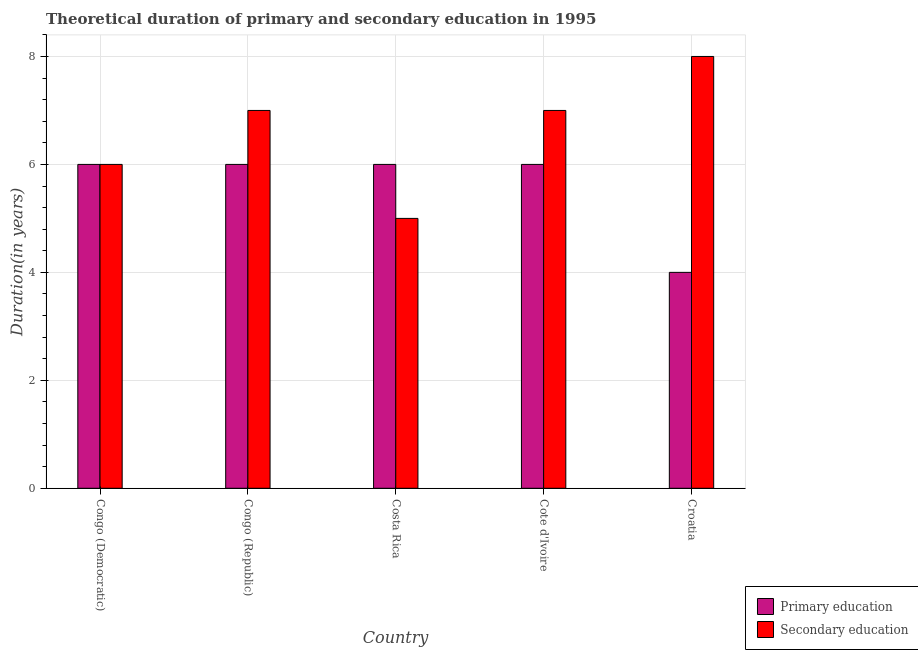How many different coloured bars are there?
Offer a terse response. 2. How many groups of bars are there?
Give a very brief answer. 5. How many bars are there on the 3rd tick from the left?
Provide a succinct answer. 2. How many bars are there on the 5th tick from the right?
Your answer should be very brief. 2. What is the label of the 2nd group of bars from the left?
Make the answer very short. Congo (Republic). In how many cases, is the number of bars for a given country not equal to the number of legend labels?
Offer a very short reply. 0. What is the duration of secondary education in Cote d'Ivoire?
Offer a very short reply. 7. Across all countries, what is the maximum duration of secondary education?
Your answer should be very brief. 8. Across all countries, what is the minimum duration of primary education?
Offer a terse response. 4. In which country was the duration of primary education maximum?
Offer a terse response. Congo (Democratic). In which country was the duration of secondary education minimum?
Make the answer very short. Costa Rica. What is the total duration of secondary education in the graph?
Offer a terse response. 33. What is the difference between the duration of secondary education in Congo (Democratic) and that in Congo (Republic)?
Your answer should be compact. -1. What is the difference between the duration of secondary education in Croatia and the duration of primary education in Cote d'Ivoire?
Provide a short and direct response. 2. What is the difference between the duration of primary education and duration of secondary education in Congo (Republic)?
Give a very brief answer. -1. What is the ratio of the duration of primary education in Cote d'Ivoire to that in Croatia?
Keep it short and to the point. 1.5. What is the difference between the highest and the second highest duration of secondary education?
Provide a succinct answer. 1. What is the difference between the highest and the lowest duration of secondary education?
Offer a terse response. 3. Is the sum of the duration of secondary education in Costa Rica and Croatia greater than the maximum duration of primary education across all countries?
Your answer should be very brief. Yes. What does the 1st bar from the left in Costa Rica represents?
Keep it short and to the point. Primary education. How many countries are there in the graph?
Give a very brief answer. 5. What is the difference between two consecutive major ticks on the Y-axis?
Make the answer very short. 2. Does the graph contain any zero values?
Offer a terse response. No. Does the graph contain grids?
Provide a short and direct response. Yes. Where does the legend appear in the graph?
Your response must be concise. Bottom right. What is the title of the graph?
Provide a short and direct response. Theoretical duration of primary and secondary education in 1995. What is the label or title of the Y-axis?
Keep it short and to the point. Duration(in years). What is the Duration(in years) in Primary education in Congo (Republic)?
Offer a very short reply. 6. What is the Duration(in years) in Primary education in Costa Rica?
Provide a short and direct response. 6. What is the Duration(in years) in Secondary education in Costa Rica?
Provide a succinct answer. 5. What is the Duration(in years) in Primary education in Cote d'Ivoire?
Your response must be concise. 6. What is the Duration(in years) in Secondary education in Cote d'Ivoire?
Provide a short and direct response. 7. What is the Duration(in years) of Primary education in Croatia?
Keep it short and to the point. 4. What is the Duration(in years) of Secondary education in Croatia?
Provide a succinct answer. 8. What is the total Duration(in years) in Secondary education in the graph?
Give a very brief answer. 33. What is the difference between the Duration(in years) in Secondary education in Congo (Democratic) and that in Costa Rica?
Provide a short and direct response. 1. What is the difference between the Duration(in years) in Secondary education in Congo (Republic) and that in Cote d'Ivoire?
Give a very brief answer. 0. What is the difference between the Duration(in years) of Secondary education in Congo (Republic) and that in Croatia?
Give a very brief answer. -1. What is the difference between the Duration(in years) of Primary education in Costa Rica and that in Cote d'Ivoire?
Give a very brief answer. 0. What is the difference between the Duration(in years) of Secondary education in Costa Rica and that in Cote d'Ivoire?
Ensure brevity in your answer.  -2. What is the difference between the Duration(in years) in Primary education in Costa Rica and that in Croatia?
Your response must be concise. 2. What is the difference between the Duration(in years) in Secondary education in Costa Rica and that in Croatia?
Your answer should be compact. -3. What is the difference between the Duration(in years) of Primary education in Cote d'Ivoire and that in Croatia?
Offer a terse response. 2. What is the difference between the Duration(in years) in Primary education in Congo (Democratic) and the Duration(in years) in Secondary education in Congo (Republic)?
Offer a very short reply. -1. What is the difference between the Duration(in years) of Primary education in Congo (Republic) and the Duration(in years) of Secondary education in Cote d'Ivoire?
Give a very brief answer. -1. What is the difference between the Duration(in years) of Primary education in Costa Rica and the Duration(in years) of Secondary education in Cote d'Ivoire?
Make the answer very short. -1. What is the difference between the Duration(in years) of Primary education in Cote d'Ivoire and the Duration(in years) of Secondary education in Croatia?
Your answer should be very brief. -2. What is the average Duration(in years) of Primary education per country?
Offer a very short reply. 5.6. What is the average Duration(in years) in Secondary education per country?
Your answer should be compact. 6.6. What is the difference between the Duration(in years) of Primary education and Duration(in years) of Secondary education in Congo (Democratic)?
Give a very brief answer. 0. What is the difference between the Duration(in years) of Primary education and Duration(in years) of Secondary education in Croatia?
Make the answer very short. -4. What is the ratio of the Duration(in years) of Primary education in Congo (Democratic) to that in Congo (Republic)?
Keep it short and to the point. 1. What is the ratio of the Duration(in years) in Secondary education in Congo (Democratic) to that in Congo (Republic)?
Provide a succinct answer. 0.86. What is the ratio of the Duration(in years) in Primary education in Congo (Democratic) to that in Costa Rica?
Ensure brevity in your answer.  1. What is the ratio of the Duration(in years) in Primary education in Congo (Republic) to that in Cote d'Ivoire?
Keep it short and to the point. 1. What is the ratio of the Duration(in years) in Secondary education in Congo (Republic) to that in Cote d'Ivoire?
Give a very brief answer. 1. What is the ratio of the Duration(in years) of Secondary education in Costa Rica to that in Cote d'Ivoire?
Ensure brevity in your answer.  0.71. What is the ratio of the Duration(in years) in Primary education in Costa Rica to that in Croatia?
Your response must be concise. 1.5. What is the difference between the highest and the second highest Duration(in years) in Primary education?
Your response must be concise. 0. What is the difference between the highest and the second highest Duration(in years) in Secondary education?
Your answer should be very brief. 1. What is the difference between the highest and the lowest Duration(in years) of Secondary education?
Provide a succinct answer. 3. 